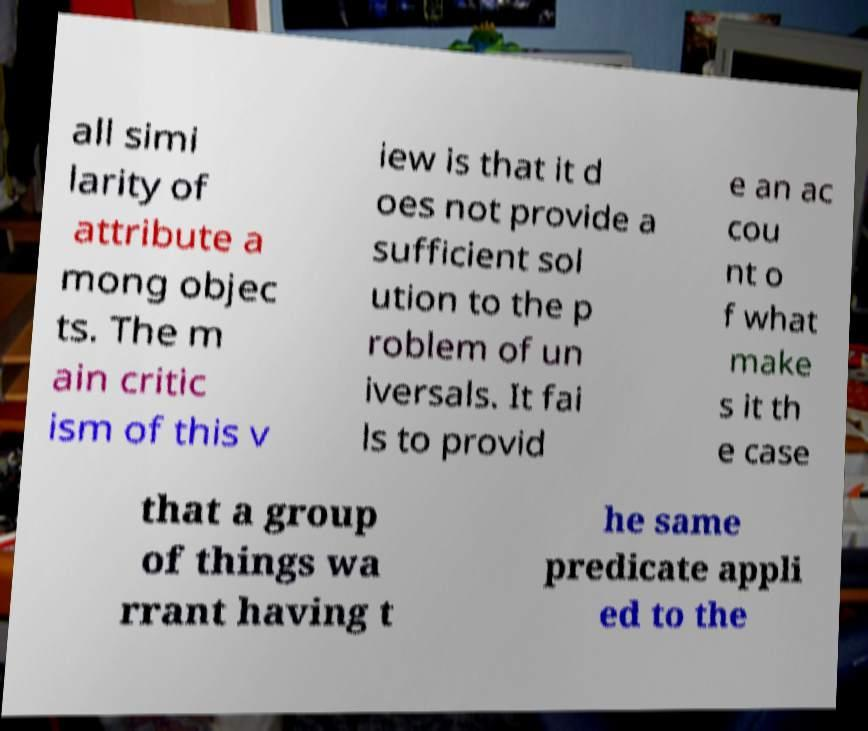For documentation purposes, I need the text within this image transcribed. Could you provide that? all simi larity of attribute a mong objec ts. The m ain critic ism of this v iew is that it d oes not provide a sufficient sol ution to the p roblem of un iversals. It fai ls to provid e an ac cou nt o f what make s it th e case that a group of things wa rrant having t he same predicate appli ed to the 